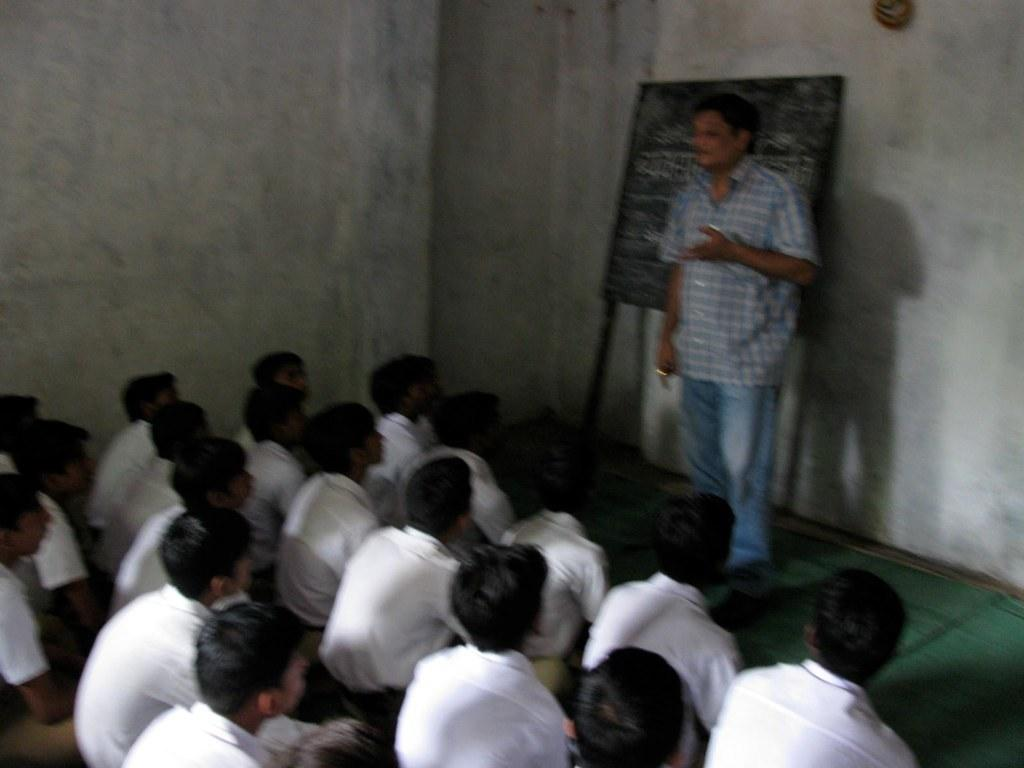What are the people in the image doing? There are persons sitting on the floor in the image. Can you describe the standing figure in the image? There is a man standing in the image. What is the purpose of the board in the image? Texts are written on a board in the image, which may suggest it is used for communication or instruction. Where else can texts be found in the image? There are texts written on the walls in the image. How many horses are present in the image? There are no horses present in the image. What type of prose can be seen written on the walls in the image? There is no prose visible in the image; only texts are present. 